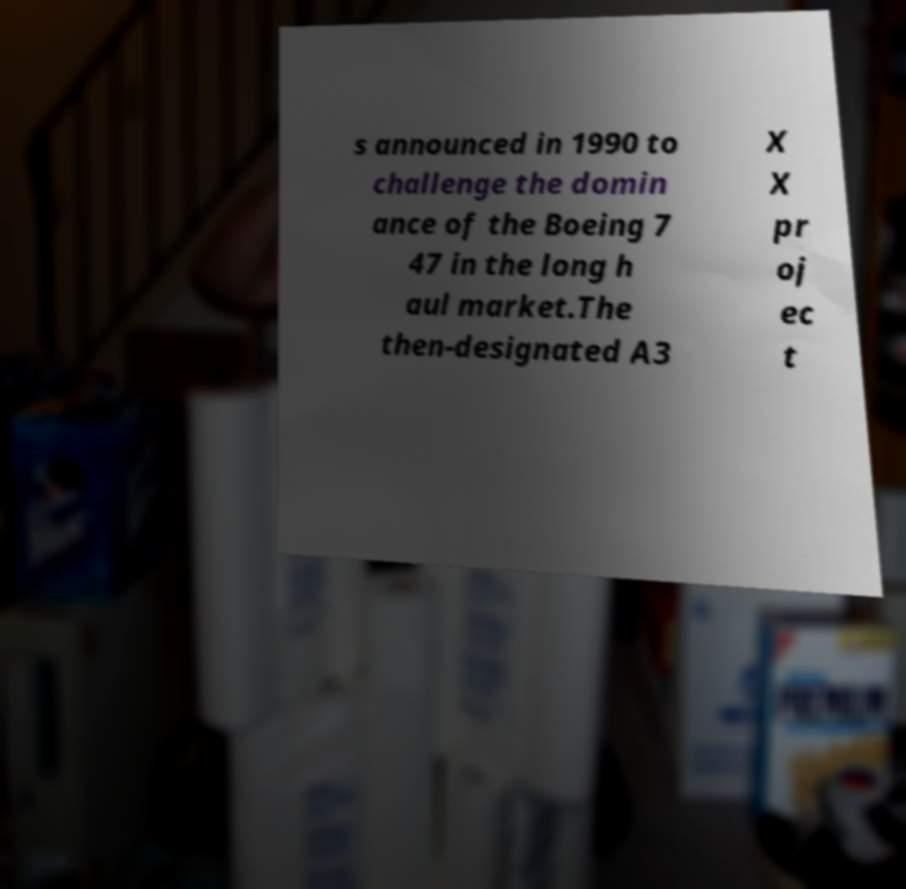Could you extract and type out the text from this image? s announced in 1990 to challenge the domin ance of the Boeing 7 47 in the long h aul market.The then-designated A3 X X pr oj ec t 